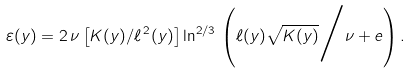<formula> <loc_0><loc_0><loc_500><loc_500>\varepsilon ( y ) = 2 \, \nu \left [ { K ( y ) } / { \ell ^ { \, 2 } ( y ) } \right ] \ln ^ { 2 / 3 } \, \left ( { \ell ( y ) } \sqrt { K ( y ) } \Big / \nu + e \right ) .</formula> 